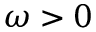<formula> <loc_0><loc_0><loc_500><loc_500>\omega > 0</formula> 